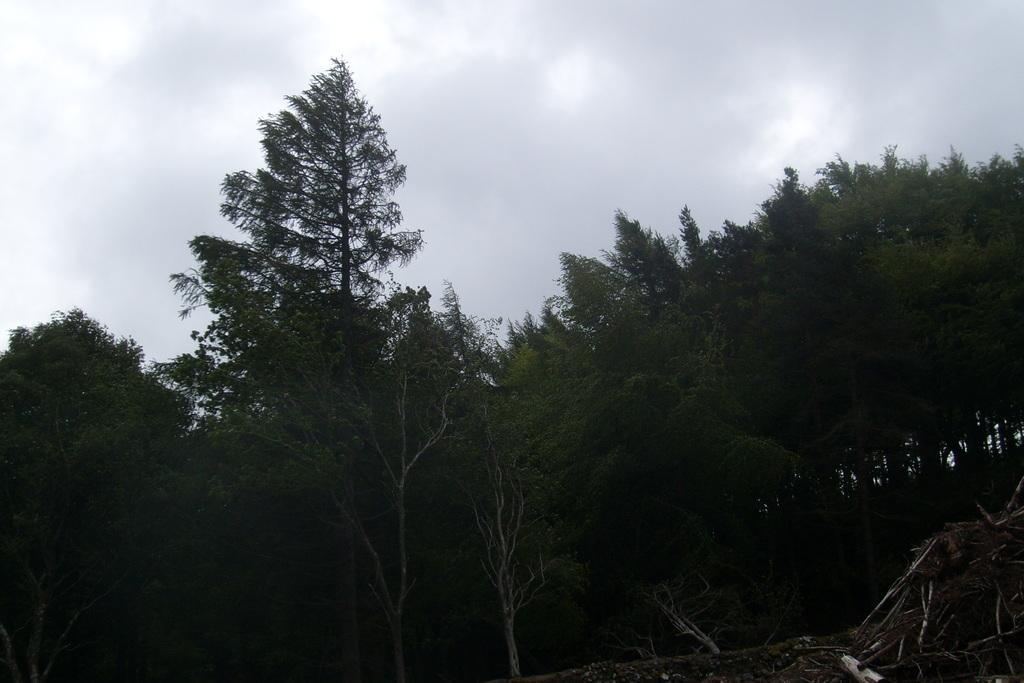Can you describe this image briefly? As we can see in the image there are trees, sky and clouds. 